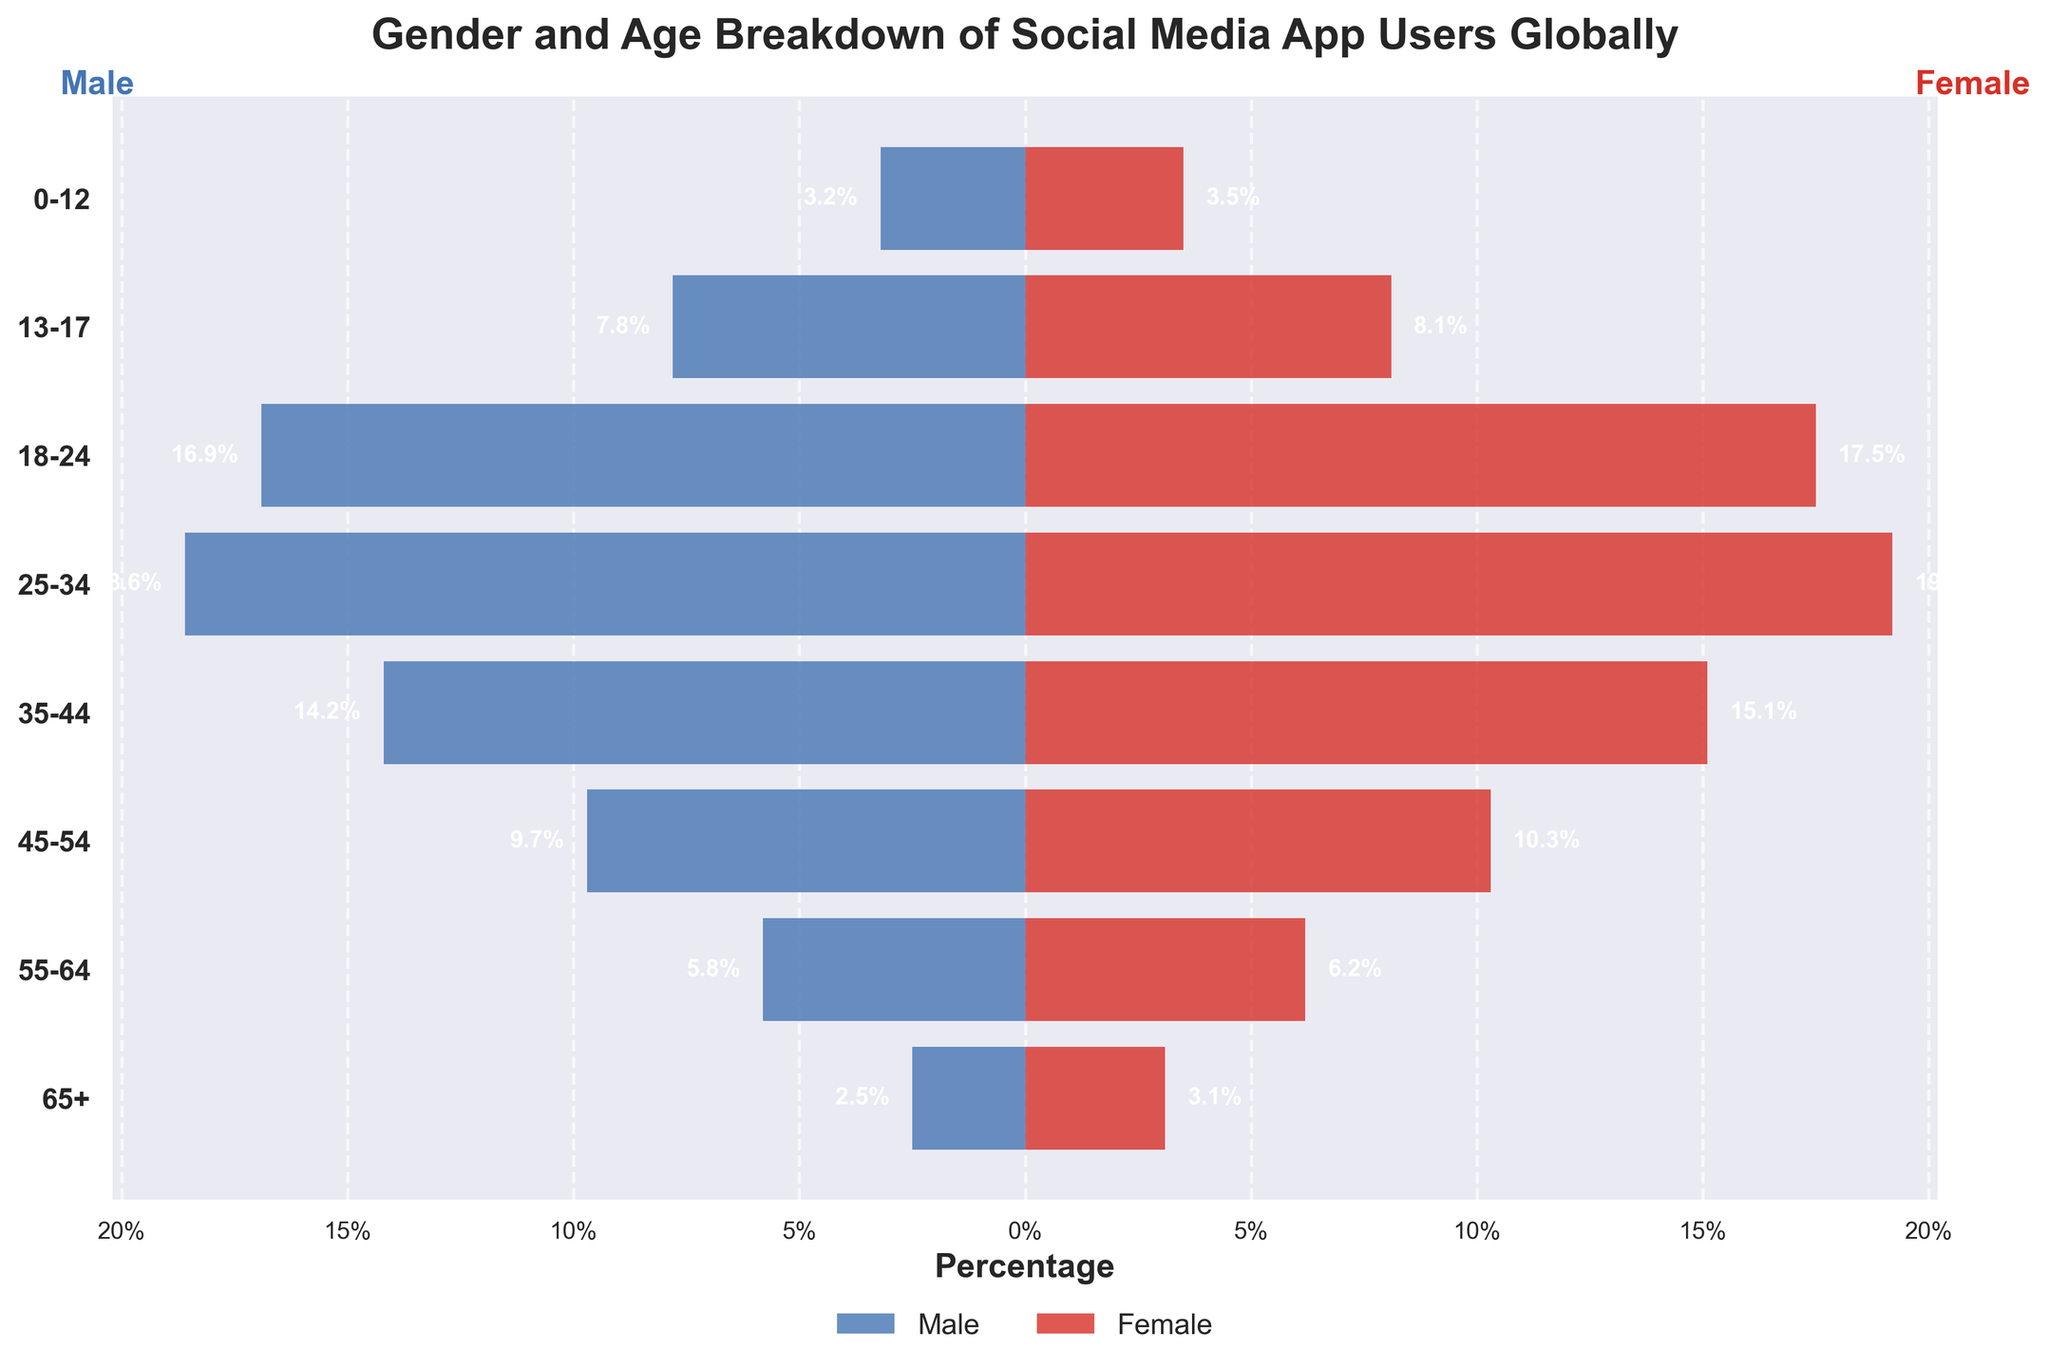What is the age group with the highest percentage of female social media app users? Look at the female bars to identify the longest bar, which represents the highest percentage. The bar for the 25-34 age group is the longest for females, indicating the highest percentage.
Answer: 25-34 Which gender has a higher percentage of users in the 45-54 age group? Compare the lengths of the male and female bars in the 45-54 age group. The female bar is longer than the male bar, indicating a higher percentage of female users.
Answer: Female How much higher is the percentage of female users compared to male users in the 25-34 age group? Subtract the percentage of male users (18.6%) from the percentage of female users (19.2%) in the 25-34 age group. This difference is 0.6%.
Answer: 0.6% Which age group has the smallest gender difference in social media app usage percentages? Calculate the difference between male and female percentages for each age group and find the smallest value. For the 13-17 age group, the difference is 0.3%, which is the smallest.
Answer: 13-17 What is the main title of the graph? The main title of the graph is displayed at the top. It reads "Gender and Age Breakdown of Social Media App Users Globally".
Answer: Gender and Age Breakdown of Social Media App Users Globally What percentage of social media app users aged 55-64 are male? Look at the length of the male bar in the 55-64 age group. The label next to the bar indicates 5.8%.
Answer: 5.8% In which age group do males constitute less than 5% of social media app users? Identify any male bar with a value less than 5%. The 65+ age group has a male percentage of 2.5%.
Answer: 65+ Between which age groups is the gender disparity the largest? Calculate the gender difference for each age group and identify the largest difference. The 45-54 age group has the largest difference, with males at 9.7% and females at 10.3%, a difference of 0.6%.
Answer: 45-54 What are the colors used to represent the male and female bars? The color of the male bars is blue, and the color of the female bars is red. These colors help distinguish between the genders.
Answer: Blue (Male), Red (Female) How does the user distribution change between the 18-24 and 25-34 age groups for both genders? Compare the lengths of the male and female bars for the 18-24 and 25-34 age groups. For males, the percentage increases from 16.9% to 18.6%. For females, the percentage increases from 17.5% to 19.2%.
Answer: Increases for both genders 